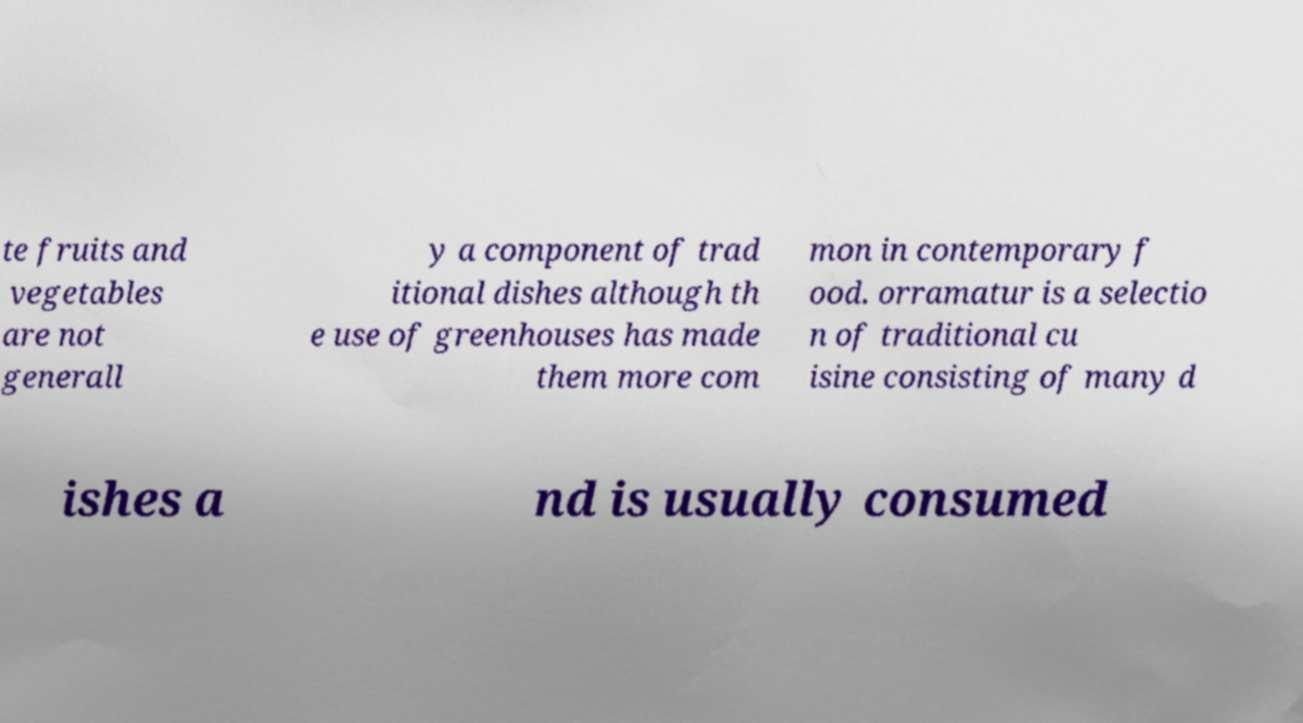Please read and relay the text visible in this image. What does it say? te fruits and vegetables are not generall y a component of trad itional dishes although th e use of greenhouses has made them more com mon in contemporary f ood. orramatur is a selectio n of traditional cu isine consisting of many d ishes a nd is usually consumed 